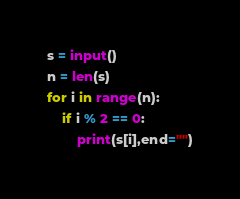<code> <loc_0><loc_0><loc_500><loc_500><_Python_>s = input()
n = len(s)
for i in range(n):
    if i % 2 == 0:
        print(s[i],end="")</code> 